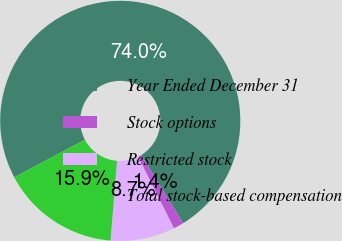Convert chart to OTSL. <chart><loc_0><loc_0><loc_500><loc_500><pie_chart><fcel>Year Ended December 31<fcel>Stock options<fcel>Restricted stock<fcel>Total stock-based compensation<nl><fcel>74.02%<fcel>1.4%<fcel>8.66%<fcel>15.92%<nl></chart> 